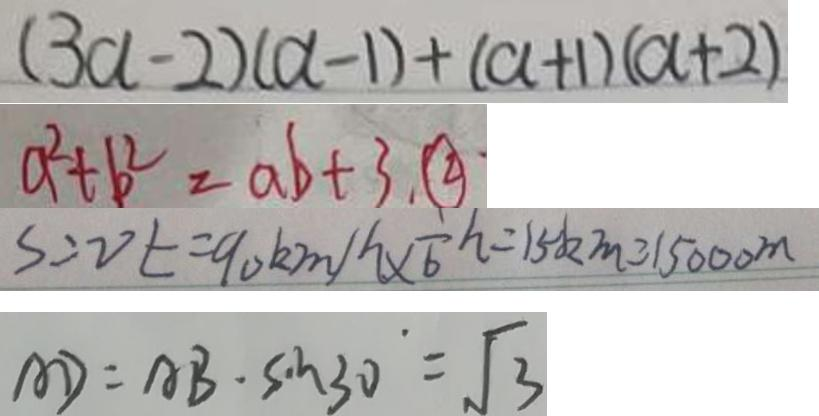<formula> <loc_0><loc_0><loc_500><loc_500>( 3 a - 2 ) ( a - 1 ) + ( a + 1 ) ( a + 2 ) 
 a ^ { 2 } + b ^ { 2 } = a b + 3 . \textcircled { 2 } 
 S = v t = 9 0 k m / \frac { 1 } { 6 } h = 1 5 k m = 1 5 0 0 0 m 
 A D = A B \cdot \sin 3 0 ^ { \cdot } = \sqrt { 3 }</formula> 